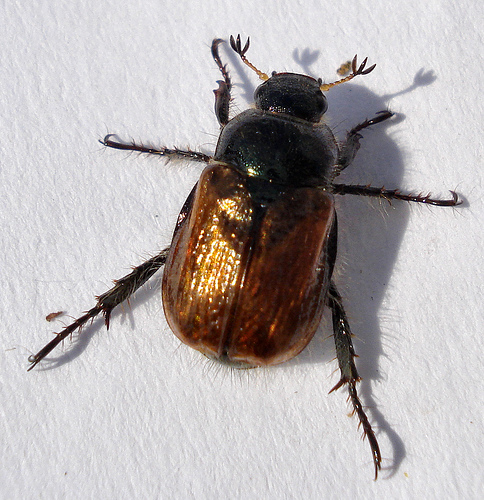<image>
Is there a cockroach on the wall? Yes. Looking at the image, I can see the cockroach is positioned on top of the wall, with the wall providing support. Where is the beetle in relation to the wall? Is it in front of the wall? Yes. The beetle is positioned in front of the wall, appearing closer to the camera viewpoint. 